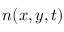<formula> <loc_0><loc_0><loc_500><loc_500>n ( x , y , t )</formula> 